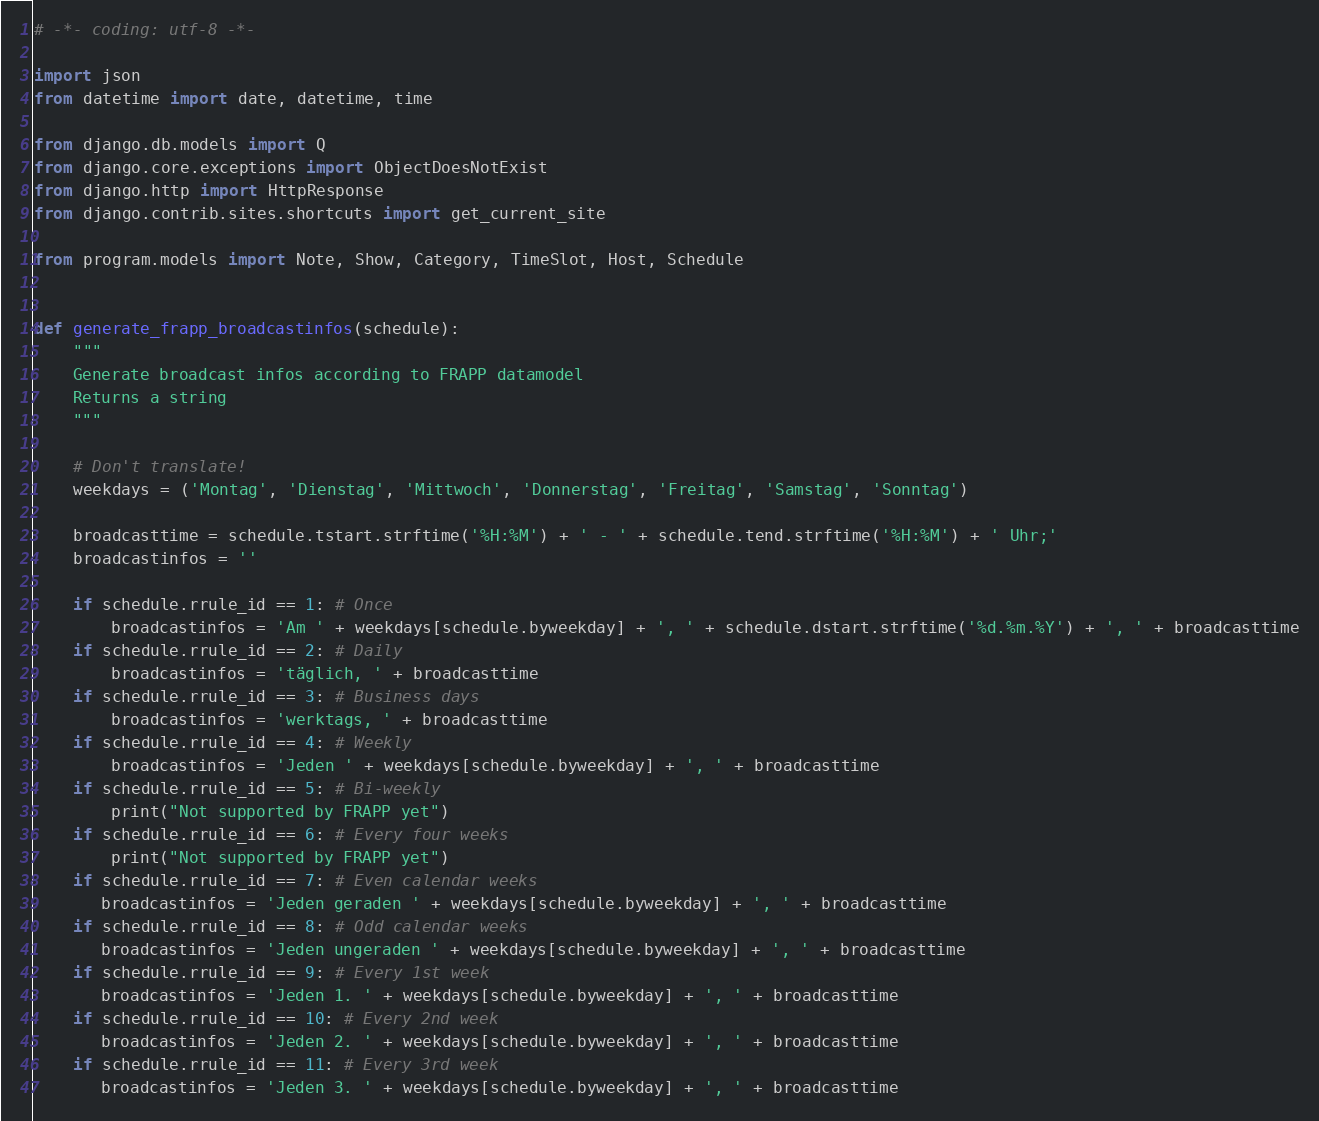Convert code to text. <code><loc_0><loc_0><loc_500><loc_500><_Python_># -*- coding: utf-8 -*-

import json
from datetime import date, datetime, time

from django.db.models import Q
from django.core.exceptions import ObjectDoesNotExist
from django.http import HttpResponse
from django.contrib.sites.shortcuts import get_current_site

from program.models import Note, Show, Category, TimeSlot, Host, Schedule


def generate_frapp_broadcastinfos(schedule):
    """
    Generate broadcast infos according to FRAPP datamodel
    Returns a string
    """

    # Don't translate!
    weekdays = ('Montag', 'Dienstag', 'Mittwoch', 'Donnerstag', 'Freitag', 'Samstag', 'Sonntag')

    broadcasttime = schedule.tstart.strftime('%H:%M') + ' - ' + schedule.tend.strftime('%H:%M') + ' Uhr;'
    broadcastinfos = ''

    if schedule.rrule_id == 1: # Once
        broadcastinfos = 'Am ' + weekdays[schedule.byweekday] + ', ' + schedule.dstart.strftime('%d.%m.%Y') + ', ' + broadcasttime
    if schedule.rrule_id == 2: # Daily
        broadcastinfos = 'täglich, ' + broadcasttime
    if schedule.rrule_id == 3: # Business days
        broadcastinfos = 'werktags, ' + broadcasttime
    if schedule.rrule_id == 4: # Weekly
        broadcastinfos = 'Jeden ' + weekdays[schedule.byweekday] + ', ' + broadcasttime
    if schedule.rrule_id == 5: # Bi-weekly
        print("Not supported by FRAPP yet")
    if schedule.rrule_id == 6: # Every four weeks
        print("Not supported by FRAPP yet")
    if schedule.rrule_id == 7: # Even calendar weeks
       broadcastinfos = 'Jeden geraden ' + weekdays[schedule.byweekday] + ', ' + broadcasttime
    if schedule.rrule_id == 8: # Odd calendar weeks
       broadcastinfos = 'Jeden ungeraden ' + weekdays[schedule.byweekday] + ', ' + broadcasttime
    if schedule.rrule_id == 9: # Every 1st week
       broadcastinfos = 'Jeden 1. ' + weekdays[schedule.byweekday] + ', ' + broadcasttime
    if schedule.rrule_id == 10: # Every 2nd week
       broadcastinfos = 'Jeden 2. ' + weekdays[schedule.byweekday] + ', ' + broadcasttime
    if schedule.rrule_id == 11: # Every 3rd week
       broadcastinfos = 'Jeden 3. ' + weekdays[schedule.byweekday] + ', ' + broadcasttime</code> 